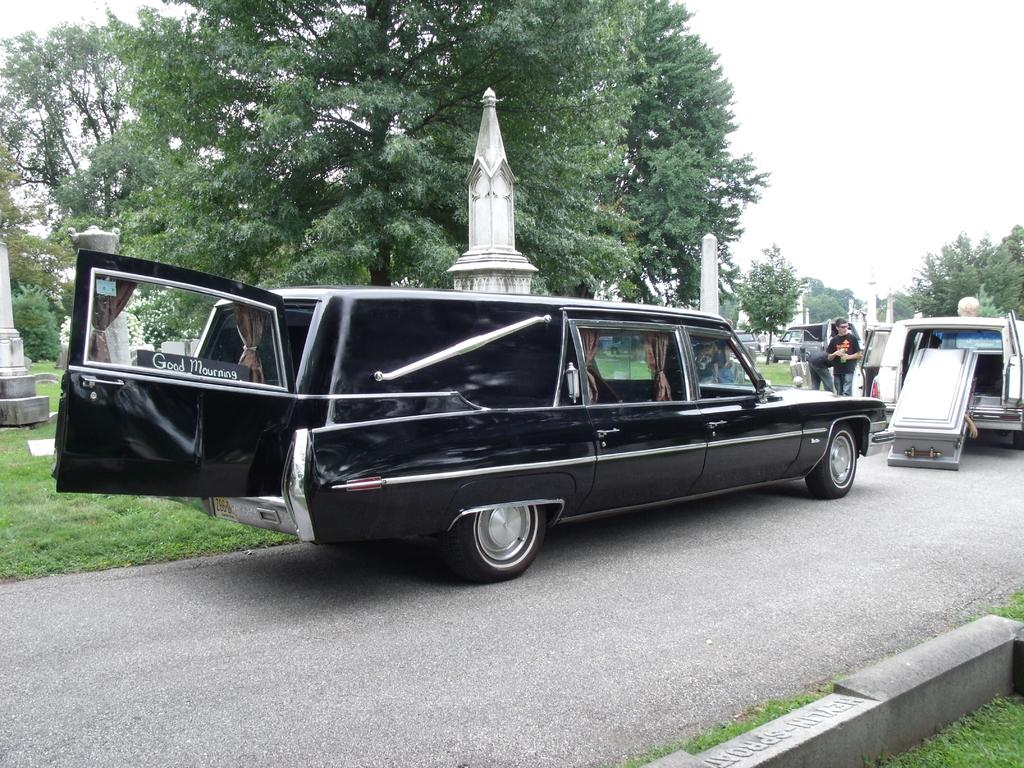What can be seen on the road in the image? There are vehicles on the road in the image. What else is present in the image besides the vehicles? There is a group of people and objects that resemble poles in the image. What type of vegetation can be seen in the image? There are trees are present in the image. What is visible in the background of the image? The sky is visible in the background of the image. Can you tell me how many governors are present in the image? There is no governor present in the image. What type of cracker is being eaten by the group of people in the image? There is no cracker present in the image; the group of people is not shown eating anything. 